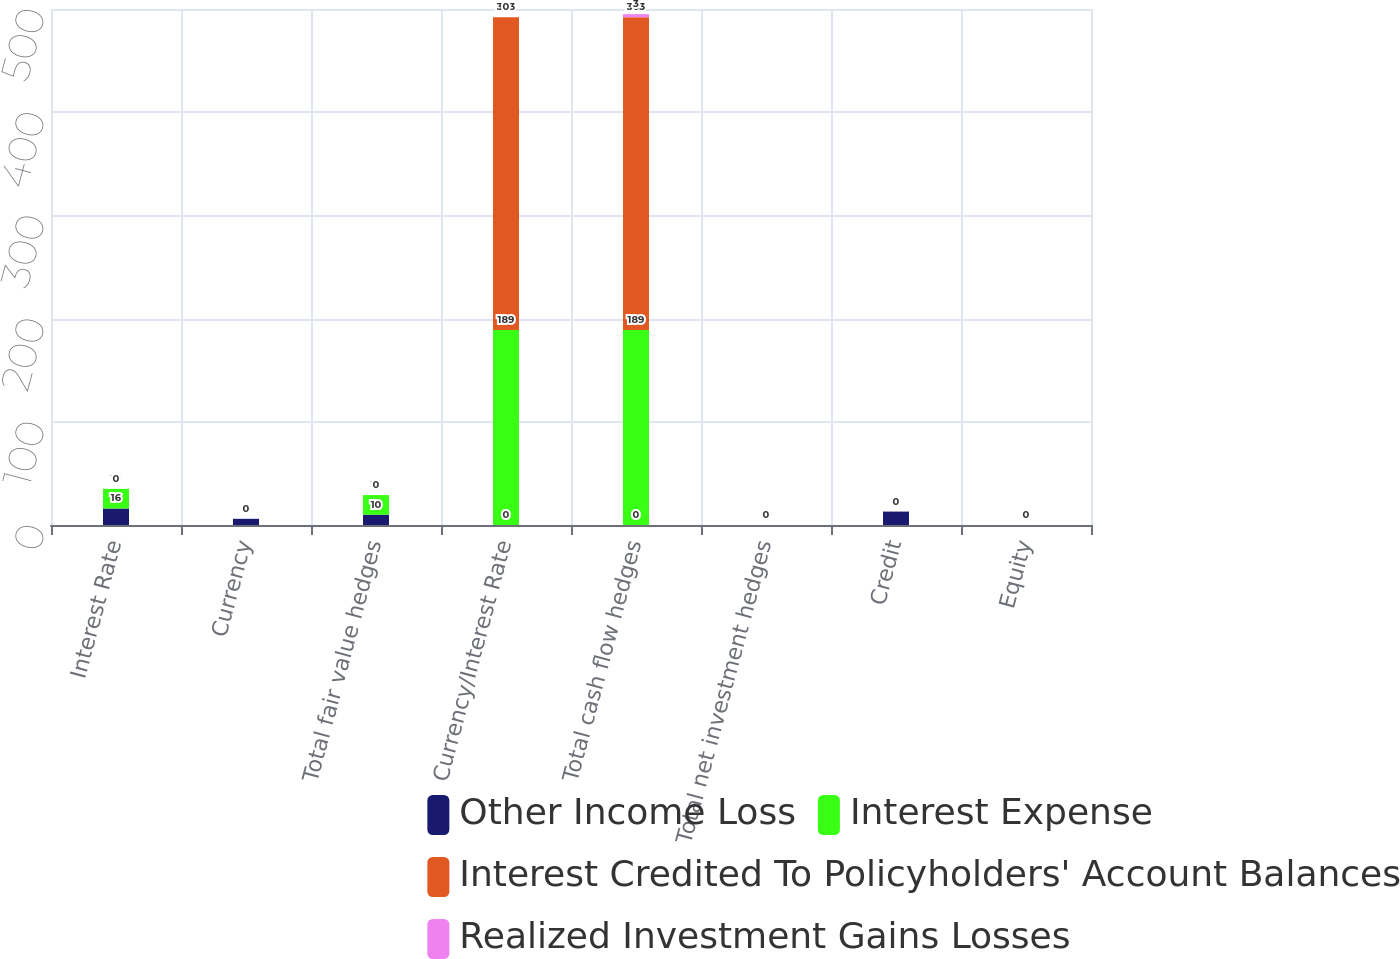Convert chart to OTSL. <chart><loc_0><loc_0><loc_500><loc_500><stacked_bar_chart><ecel><fcel>Interest Rate<fcel>Currency<fcel>Total fair value hedges<fcel>Currency/Interest Rate<fcel>Total cash flow hedges<fcel>Total net investment hedges<fcel>Credit<fcel>Equity<nl><fcel>Other Income Loss<fcel>16<fcel>6<fcel>10<fcel>0<fcel>0<fcel>0<fcel>13<fcel>0<nl><fcel>Interest Expense<fcel>19<fcel>0<fcel>19<fcel>189<fcel>189<fcel>0<fcel>0<fcel>0<nl><fcel>Interest Credited To Policyholders' Account Balances<fcel>0<fcel>0<fcel>0<fcel>303<fcel>303<fcel>0<fcel>0<fcel>0<nl><fcel>Realized Investment Gains Losses<fcel>0<fcel>0<fcel>0<fcel>0<fcel>3<fcel>0<fcel>0<fcel>0<nl></chart> 